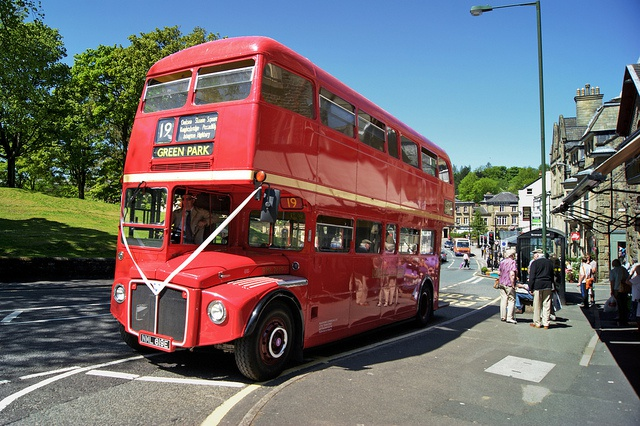Describe the objects in this image and their specific colors. I can see bus in black, maroon, salmon, and brown tones, people in black, ivory, darkgray, and beige tones, people in black, maroon, gray, and brown tones, people in black, lightgray, darkgray, lightpink, and violet tones, and people in black, darkblue, darkgray, and maroon tones in this image. 